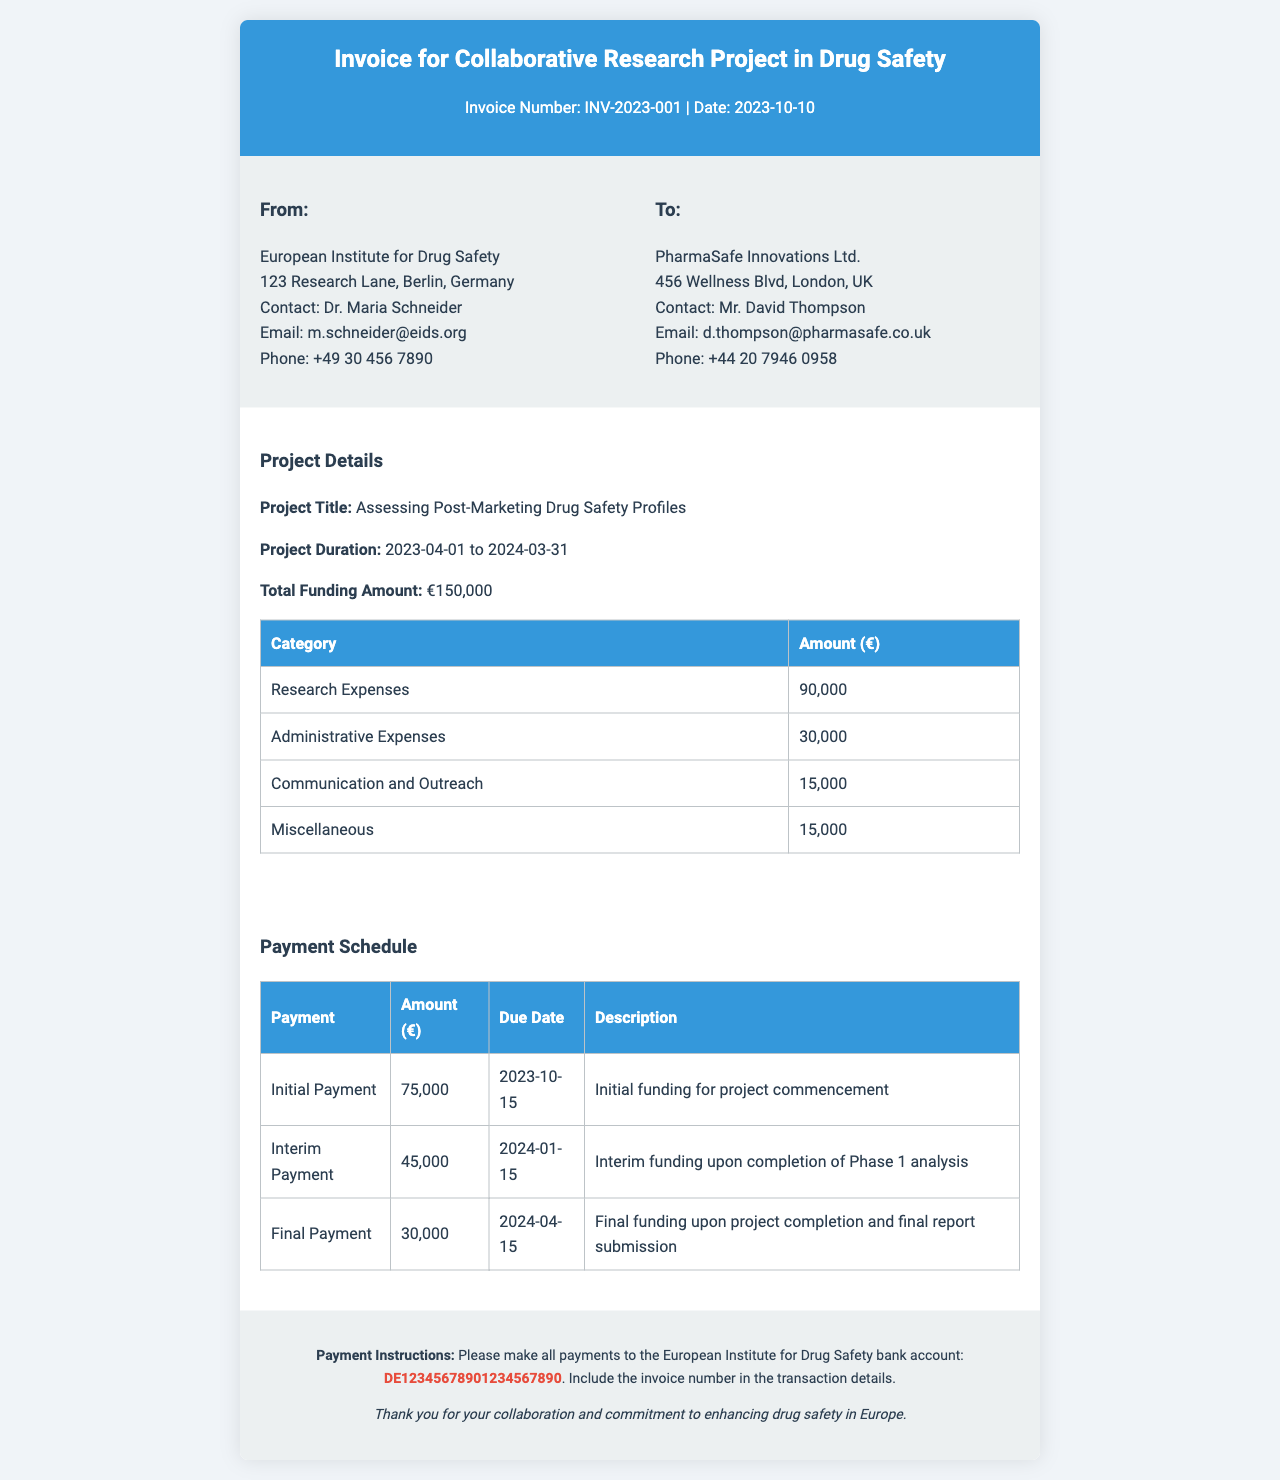What is the invoice number? The invoice number is specified at the top of the document, indicating a unique identifier for this transaction.
Answer: INV-2023-001 What is the total funding amount? The total funding amount is listed under the project details section, summarizing the financial support for the research project.
Answer: €150,000 Who is the contact for the European Institute for Drug Safety? The contact person's name is provided in the "From" section of the invoice, identifying who to reach out to for inquiries.
Answer: Dr. Maria Schneider What is the due date for the Final Payment? The due date for the Final Payment is detailed in the payment schedule, indicating when the final funding must be settled.
Answer: 2024-04-15 How much is the Initial Payment? The amount for the Initial Payment is specified in the payment schedule, showing the initial funding allocation for the project commencement.
Answer: €75,000 What is the project title? The project title is highlighted in the project details section, indicating the focus of the collaborative research effort.
Answer: Assessing Post-Marketing Drug Safety Profiles How much is allocated for Administrative Expenses? The allocation for Administrative Expenses is found in the detailed funding distribution table, specifying the budget for this category.
Answer: 30,000 Who is the recipient of the invoice? The recipient is specified in the "To" section, indicating the organization responsible for payment.
Answer: PharmaSafe Innovations Ltd What is the purpose of the Interim Payment? The description for the Interim Payment in the payment schedule explains its purpose and when it is to be disbursed.
Answer: Interim funding upon completion of Phase 1 analysis 